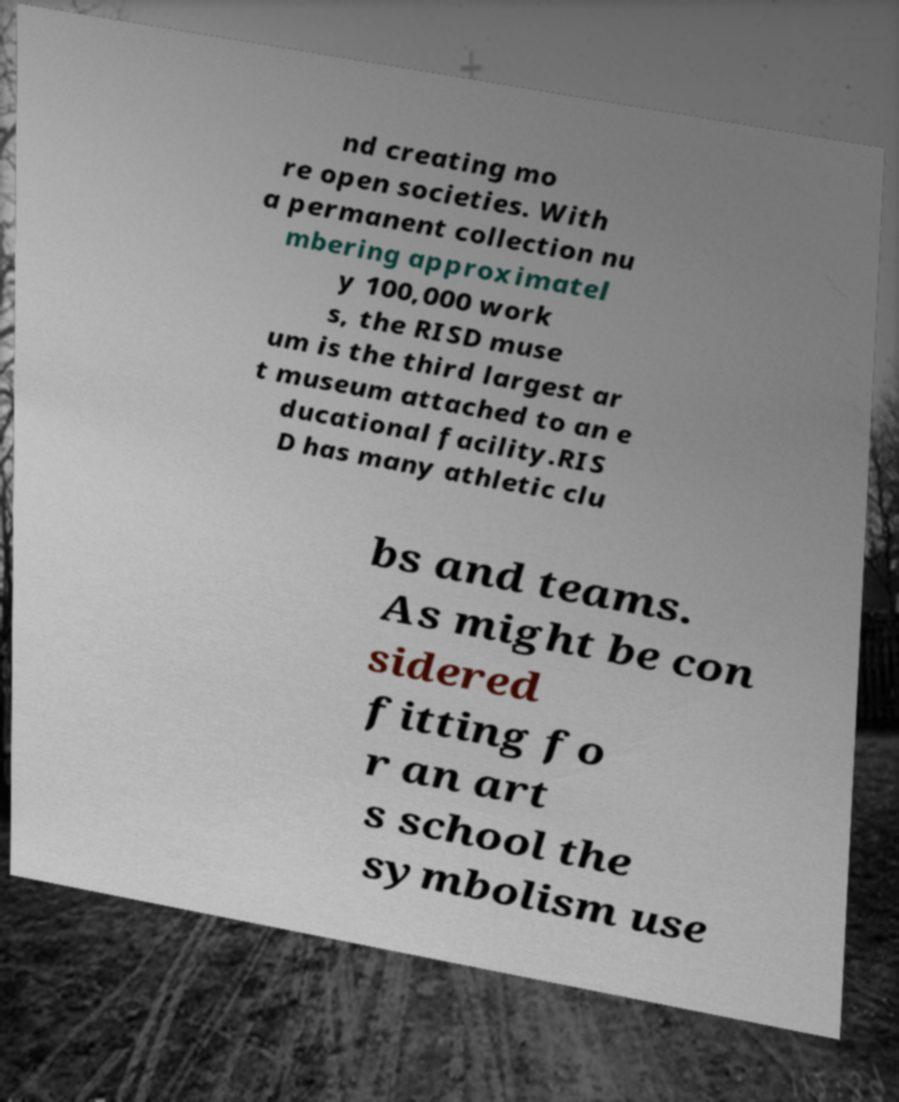What messages or text are displayed in this image? I need them in a readable, typed format. nd creating mo re open societies. With a permanent collection nu mbering approximatel y 100,000 work s, the RISD muse um is the third largest ar t museum attached to an e ducational facility.RIS D has many athletic clu bs and teams. As might be con sidered fitting fo r an art s school the symbolism use 